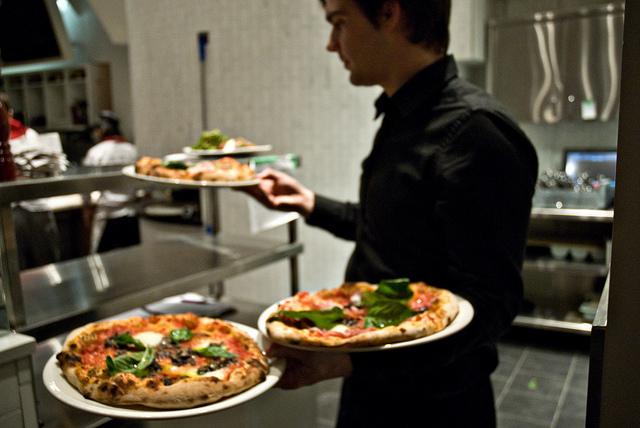Is this the chef or the waiter?
Quick response, please. Waiter. How many plates of food are visible in the picture?
Keep it brief. 4. What does this restaurant specialize in?
Write a very short answer. Pizza. 